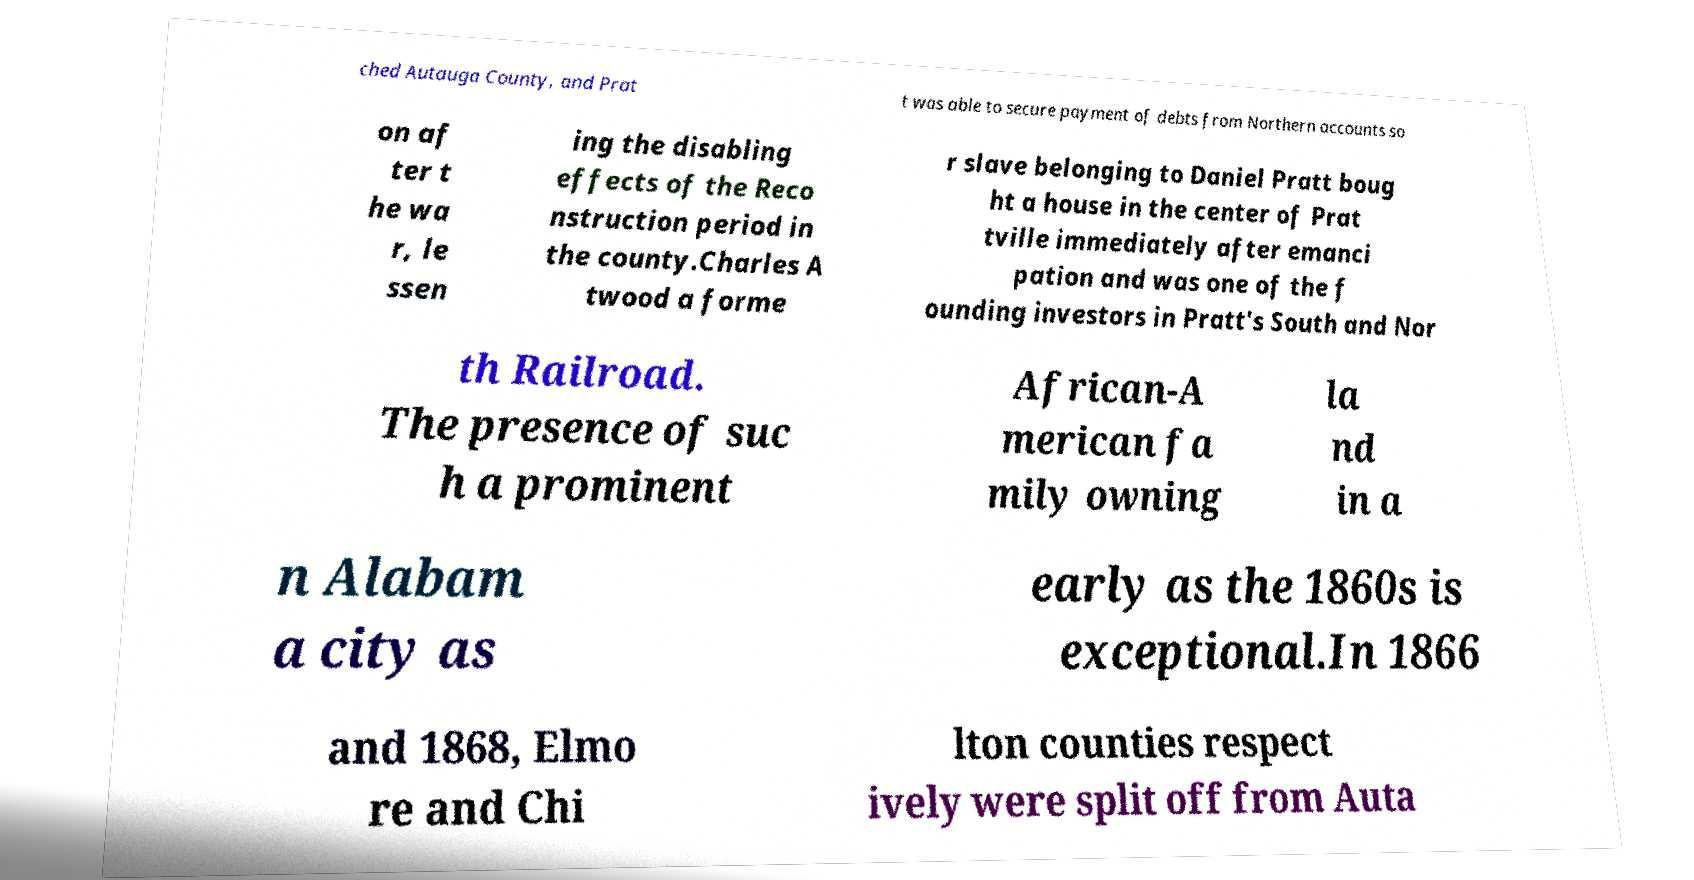Could you extract and type out the text from this image? ched Autauga County, and Prat t was able to secure payment of debts from Northern accounts so on af ter t he wa r, le ssen ing the disabling effects of the Reco nstruction period in the county.Charles A twood a forme r slave belonging to Daniel Pratt boug ht a house in the center of Prat tville immediately after emanci pation and was one of the f ounding investors in Pratt's South and Nor th Railroad. The presence of suc h a prominent African-A merican fa mily owning la nd in a n Alabam a city as early as the 1860s is exceptional.In 1866 and 1868, Elmo re and Chi lton counties respect ively were split off from Auta 